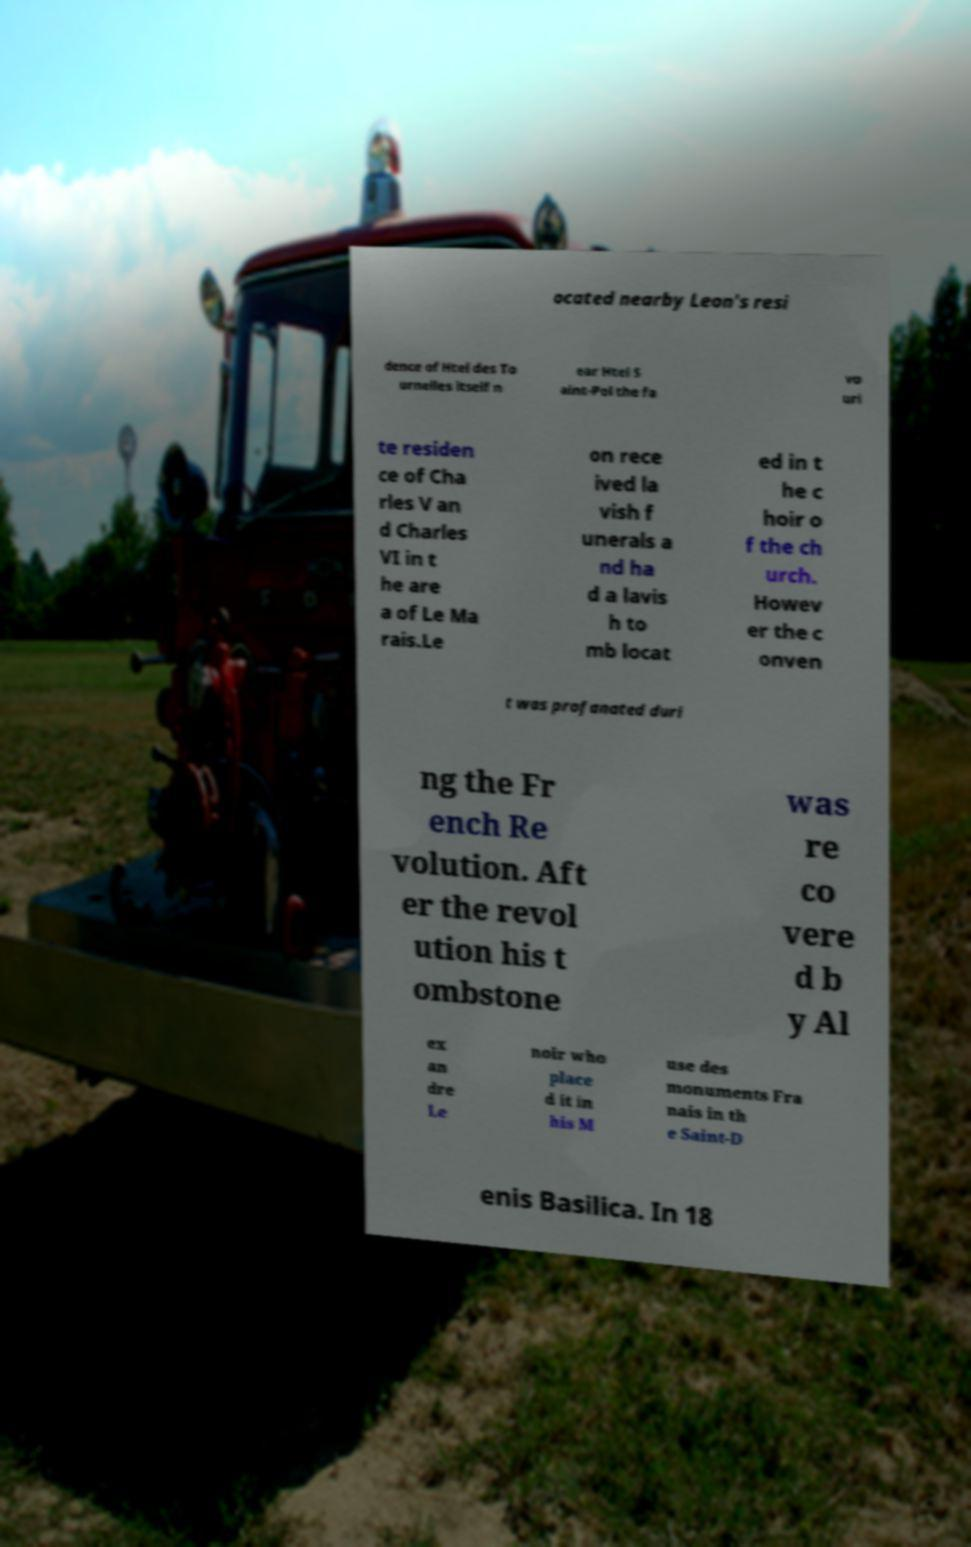Please identify and transcribe the text found in this image. ocated nearby Leon's resi dence of Htel des To urnelles itself n ear Htel S aint-Pol the fa vo uri te residen ce of Cha rles V an d Charles VI in t he are a of Le Ma rais.Le on rece ived la vish f unerals a nd ha d a lavis h to mb locat ed in t he c hoir o f the ch urch. Howev er the c onven t was profanated duri ng the Fr ench Re volution. Aft er the revol ution his t ombstone was re co vere d b y Al ex an dre Le noir who place d it in his M use des monuments Fra nais in th e Saint-D enis Basilica. In 18 